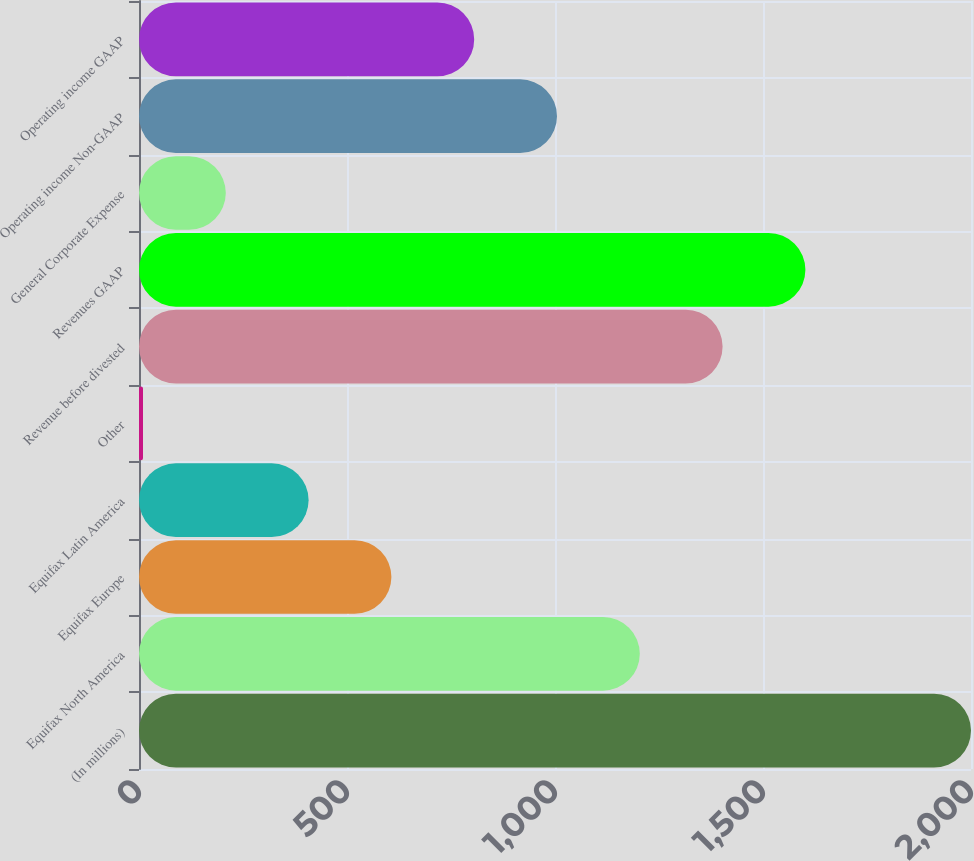Convert chart. <chart><loc_0><loc_0><loc_500><loc_500><bar_chart><fcel>(In millions)<fcel>Equifax North America<fcel>Equifax Europe<fcel>Equifax Latin America<fcel>Other<fcel>Revenue before divested<fcel>Revenues GAAP<fcel>General Corporate Expense<fcel>Operating income Non-GAAP<fcel>Operating income GAAP<nl><fcel>2000<fcel>1203.84<fcel>606.72<fcel>407.68<fcel>9.6<fcel>1402.88<fcel>1601.92<fcel>208.64<fcel>1004.8<fcel>805.76<nl></chart> 